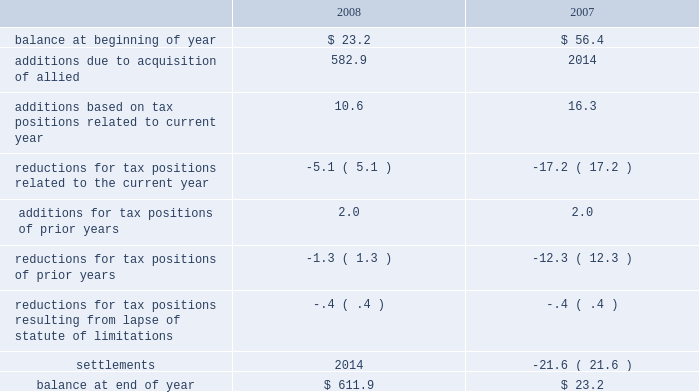In july 2006 , the fasb issued fin 48 which clarifies the accounting for income taxes by prescribing the minimum recognition threshold a tax position is required to meet before being recognized in the financial statements .
Fin 48 also provides guidance on derecognition , measurement , classification , interest and penalties , accounting in interim periods and transition , and required expanded disclosure with respect to the uncertainty in income taxes .
We adopted the provisions of fin 48 effective january 1 , 2007 .
A reconciliation of the beginning and ending amount of gross unrecognized tax benefits for the years ended december 31 is as follows ( in millions ) : .
Included in the balance at december 31 , 2008 and 2007 are approximately $ 461.0 million and $ 7.7 million , respectively , of unrecognized tax benefits ( net of the federal benefit on state issues ) that , if recognized , would affect the effective income tax rate in future periods .
Sfas 141 ( r ) is effective for financial statements issued for fiscal years beginning after december 15 , 2008 .
Sfas 141 ( r ) significantly changes the treatment of acquired uncertain tax liabilities .
Under sfas 141 , changes in acquired uncertain tax liabilities were recognized through goodwill .
Under sfas 141 ( r ) , changes in acquired unrecognized tax liabilities are recognized through the income tax provision .
As of december 31 , 2008 , $ 582.9 million of the $ 611.9 million of unrecognized tax benefits related to tax positions allied had taken prior to the merger .
Of the $ 582.9 million of acquired unrecognized benefits , $ 449.6 million , if recognized in the income tax provision , would affect our effective tax rate .
We recognize interest and penalties as incurred within the provision for income taxes in the consolidated statements of income .
Related to the unrecognized tax benefits noted above , we accrued penalties of $ .2 million and interest of $ 5.2 million during 2008 , and , in total as of december 31 , 2008 , have recognized a liability for penalties of $ 88.1 million and interest of $ 180.0 million .
During 2007 , we accrued interest of $ .9 million and , in total as of december 31 , 2007 , had recognized a liability for penalties and interest of $ 5.5 million .
Gross unrecognized tax benefits that we expect to settle in the following twelve months are in the range of $ 10.0 million to $ 20.0 million .
It is reasonably possible that the amount of unrecognized tax benefits will increase or decrease in the next twelve months .
We and our subsidiaries are subject to income tax in the u.s .
And puerto rico , as well as income tax in multiple state jurisdictions .
We have acquired allied 2019s open tax periods as part of the acquisition .
Allied is currently under examination or administrative review by various state and federal taxing authorities for certain tax years , including federal income tax audits for calendar years 2000 through 2006 .
We are also engaged in tax litigation related to our risk management companies which are subsidiaries of allied .
These matters are further discussed below .
We are subject to various federal , foreign , state and local tax rules and regulations .
Our compliance with such rules and regulations is periodically audited by tax authorities .
These authorities may challenge the republic services , inc .
And subsidiaries notes to consolidated financial statements %%transmsg*** transmitting job : p14076 pcn : 123000000 ***%%pcmsg|121 |00050|yes|no|03/01/2009 18:23|0|0|page is valid , no graphics -- color : d| .
In 2008 what was the change in the gross unrecognized tax benefits in millions? 
Computations: (611.9 - 23.2)
Answer: 588.7. In july 2006 , the fasb issued fin 48 which clarifies the accounting for income taxes by prescribing the minimum recognition threshold a tax position is required to meet before being recognized in the financial statements .
Fin 48 also provides guidance on derecognition , measurement , classification , interest and penalties , accounting in interim periods and transition , and required expanded disclosure with respect to the uncertainty in income taxes .
We adopted the provisions of fin 48 effective january 1 , 2007 .
A reconciliation of the beginning and ending amount of gross unrecognized tax benefits for the years ended december 31 is as follows ( in millions ) : .
Included in the balance at december 31 , 2008 and 2007 are approximately $ 461.0 million and $ 7.7 million , respectively , of unrecognized tax benefits ( net of the federal benefit on state issues ) that , if recognized , would affect the effective income tax rate in future periods .
Sfas 141 ( r ) is effective for financial statements issued for fiscal years beginning after december 15 , 2008 .
Sfas 141 ( r ) significantly changes the treatment of acquired uncertain tax liabilities .
Under sfas 141 , changes in acquired uncertain tax liabilities were recognized through goodwill .
Under sfas 141 ( r ) , changes in acquired unrecognized tax liabilities are recognized through the income tax provision .
As of december 31 , 2008 , $ 582.9 million of the $ 611.9 million of unrecognized tax benefits related to tax positions allied had taken prior to the merger .
Of the $ 582.9 million of acquired unrecognized benefits , $ 449.6 million , if recognized in the income tax provision , would affect our effective tax rate .
We recognize interest and penalties as incurred within the provision for income taxes in the consolidated statements of income .
Related to the unrecognized tax benefits noted above , we accrued penalties of $ .2 million and interest of $ 5.2 million during 2008 , and , in total as of december 31 , 2008 , have recognized a liability for penalties of $ 88.1 million and interest of $ 180.0 million .
During 2007 , we accrued interest of $ .9 million and , in total as of december 31 , 2007 , had recognized a liability for penalties and interest of $ 5.5 million .
Gross unrecognized tax benefits that we expect to settle in the following twelve months are in the range of $ 10.0 million to $ 20.0 million .
It is reasonably possible that the amount of unrecognized tax benefits will increase or decrease in the next twelve months .
We and our subsidiaries are subject to income tax in the u.s .
And puerto rico , as well as income tax in multiple state jurisdictions .
We have acquired allied 2019s open tax periods as part of the acquisition .
Allied is currently under examination or administrative review by various state and federal taxing authorities for certain tax years , including federal income tax audits for calendar years 2000 through 2006 .
We are also engaged in tax litigation related to our risk management companies which are subsidiaries of allied .
These matters are further discussed below .
We are subject to various federal , foreign , state and local tax rules and regulations .
Our compliance with such rules and regulations is periodically audited by tax authorities .
These authorities may challenge the republic services , inc .
And subsidiaries notes to consolidated financial statements %%transmsg*** transmitting job : p14076 pcn : 123000000 ***%%pcmsg|121 |00050|yes|no|03/01/2009 18:23|0|0|page is valid , no graphics -- color : d| .
As of december 312008 what was the percent of the unrecognized tax benefits related to tax positions allied had taken prior to the merger .? 
Rationale: in this case the percent is the amount divide by the total amount of unrecognized tax benefits in 2008
Computations: (582.9 / 611.9)
Answer: 0.95261. 